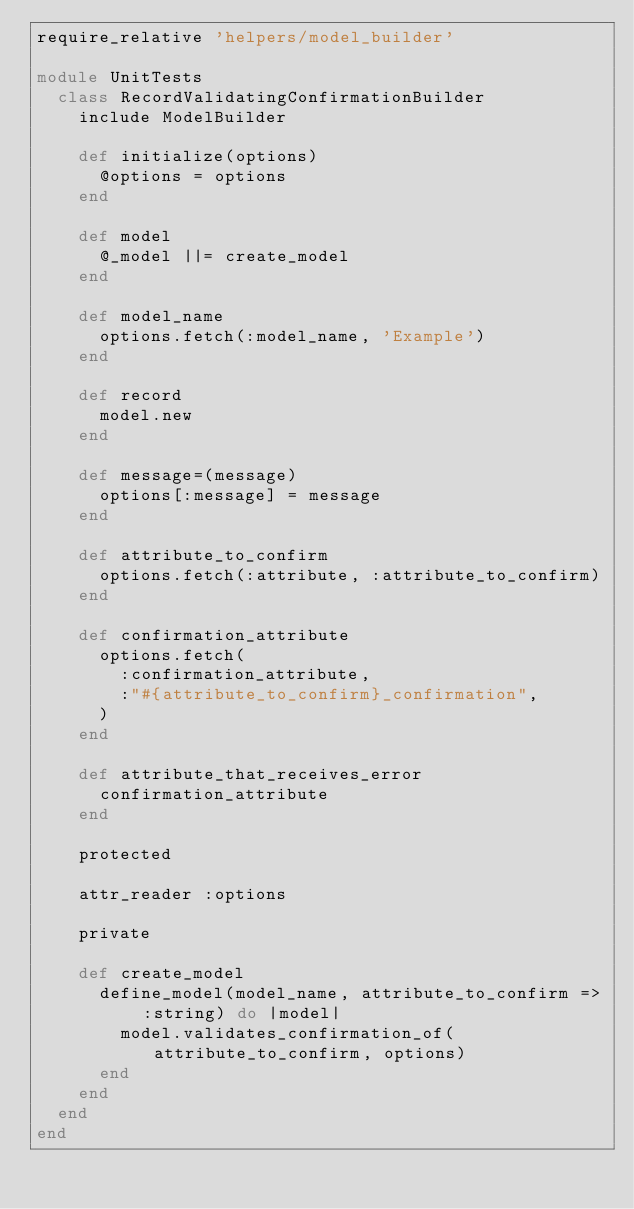Convert code to text. <code><loc_0><loc_0><loc_500><loc_500><_Ruby_>require_relative 'helpers/model_builder'

module UnitTests
  class RecordValidatingConfirmationBuilder
    include ModelBuilder

    def initialize(options)
      @options = options
    end

    def model
      @_model ||= create_model
    end

    def model_name
      options.fetch(:model_name, 'Example')
    end

    def record
      model.new
    end

    def message=(message)
      options[:message] = message
    end

    def attribute_to_confirm
      options.fetch(:attribute, :attribute_to_confirm)
    end

    def confirmation_attribute
      options.fetch(
        :confirmation_attribute,
        :"#{attribute_to_confirm}_confirmation",
      )
    end

    def attribute_that_receives_error
      confirmation_attribute
    end

    protected

    attr_reader :options

    private

    def create_model
      define_model(model_name, attribute_to_confirm => :string) do |model|
        model.validates_confirmation_of(attribute_to_confirm, options)
      end
    end
  end
end
</code> 